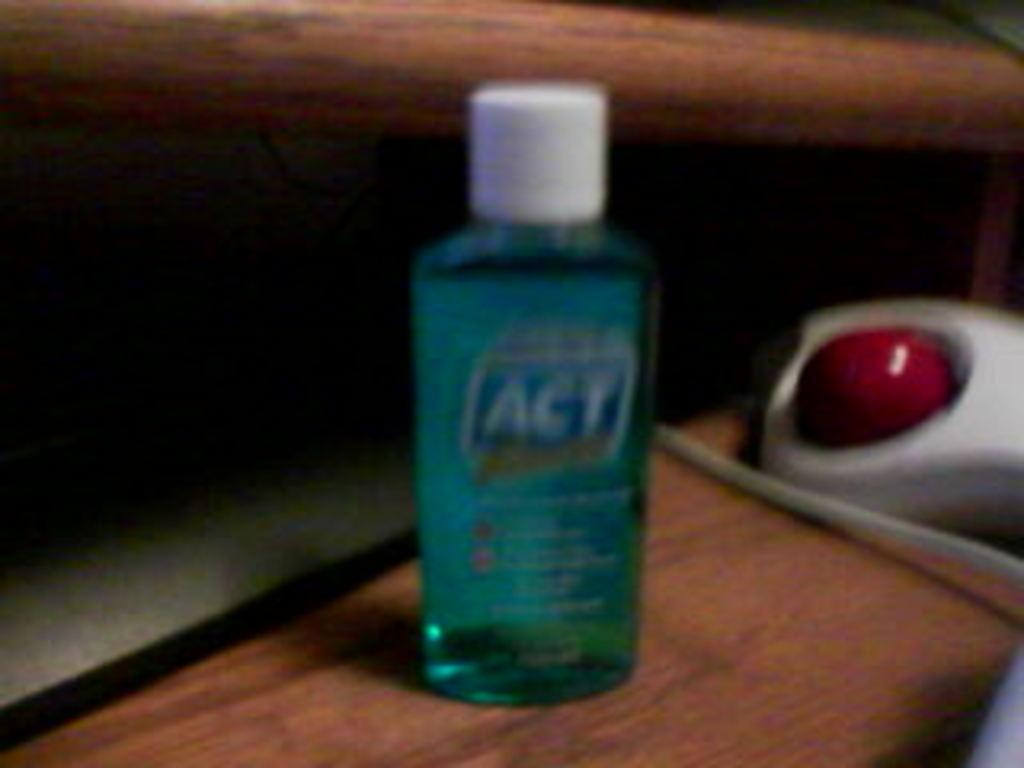What is the color of the liquid in the bottle in the image? The liquid in the bottle is blue. What is the bottle placed on in the image? The bottle is on a wooden table. What is the color of the button in the image? The button is red. What is the substance surrounding the red button in the image? The red button is on a white substance. How close is the red button to the bottle in the image? The red button is beside the bottle. Are there any fairies visible in the image? No, there are no fairies present in the image. What type of potato is being sold in the shop in the image? There is no shop or potato present in the image. 